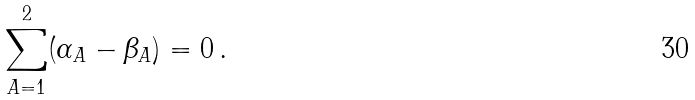Convert formula to latex. <formula><loc_0><loc_0><loc_500><loc_500>\sum _ { A = 1 } ^ { 2 } ( \alpha _ { A } - \beta _ { A } ) = 0 \, .</formula> 